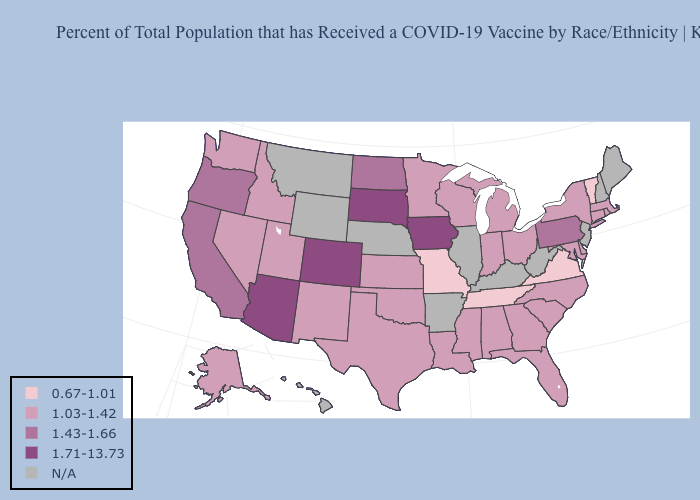Among the states that border New Mexico , does Utah have the lowest value?
Concise answer only. Yes. What is the lowest value in states that border Kentucky?
Give a very brief answer. 0.67-1.01. Does the first symbol in the legend represent the smallest category?
Keep it brief. Yes. Which states have the highest value in the USA?
Keep it brief. Arizona, Colorado, Iowa, South Dakota. Name the states that have a value in the range 1.71-13.73?
Be succinct. Arizona, Colorado, Iowa, South Dakota. What is the highest value in the USA?
Concise answer only. 1.71-13.73. Name the states that have a value in the range 0.67-1.01?
Keep it brief. Missouri, Tennessee, Vermont, Virginia. Is the legend a continuous bar?
Keep it brief. No. What is the value of New Jersey?
Concise answer only. N/A. What is the value of Minnesota?
Write a very short answer. 1.03-1.42. What is the highest value in states that border Vermont?
Keep it brief. 1.03-1.42. Name the states that have a value in the range 1.43-1.66?
Quick response, please. California, North Dakota, Oregon, Pennsylvania. Among the states that border Michigan , which have the highest value?
Quick response, please. Indiana, Ohio, Wisconsin. 